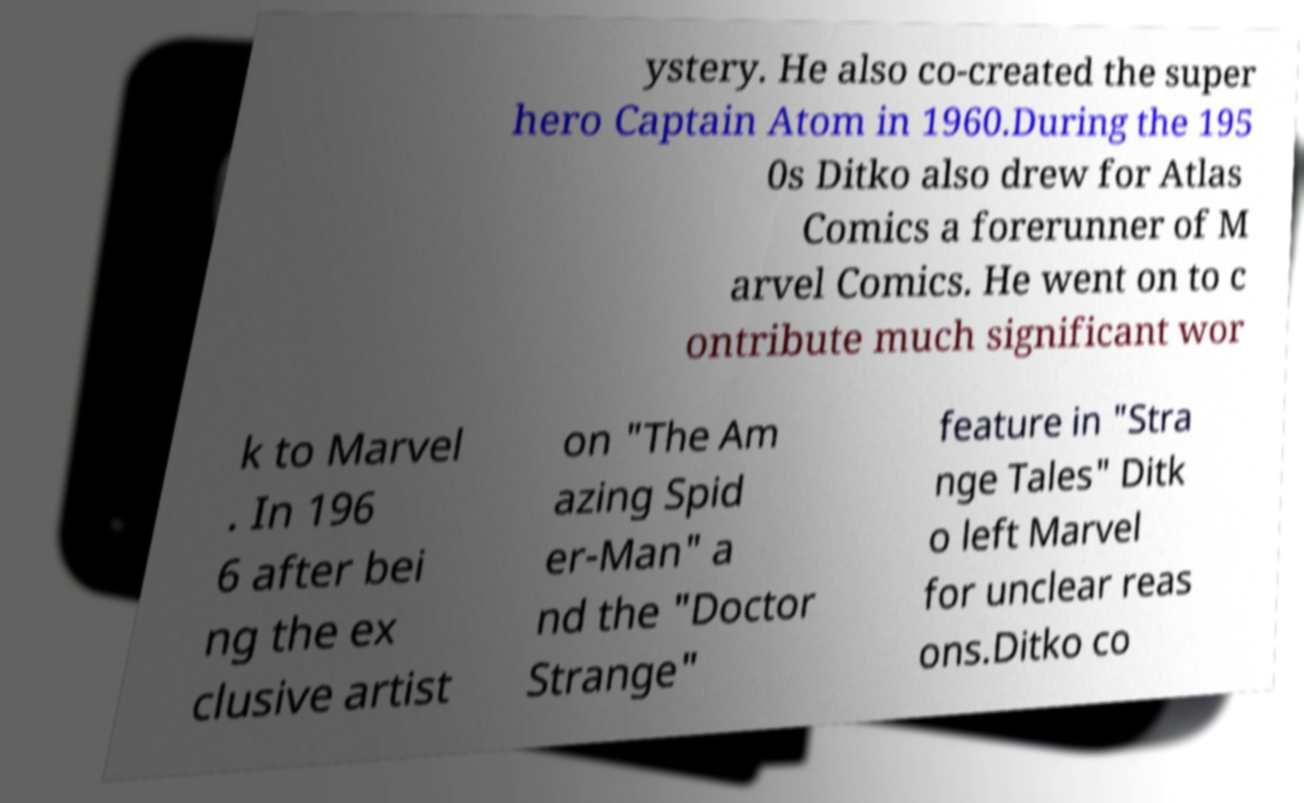Please read and relay the text visible in this image. What does it say? ystery. He also co-created the super hero Captain Atom in 1960.During the 195 0s Ditko also drew for Atlas Comics a forerunner of M arvel Comics. He went on to c ontribute much significant wor k to Marvel . In 196 6 after bei ng the ex clusive artist on "The Am azing Spid er-Man" a nd the "Doctor Strange" feature in "Stra nge Tales" Ditk o left Marvel for unclear reas ons.Ditko co 